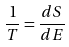<formula> <loc_0><loc_0><loc_500><loc_500>\frac { 1 } { T } = \frac { d S } { d E }</formula> 